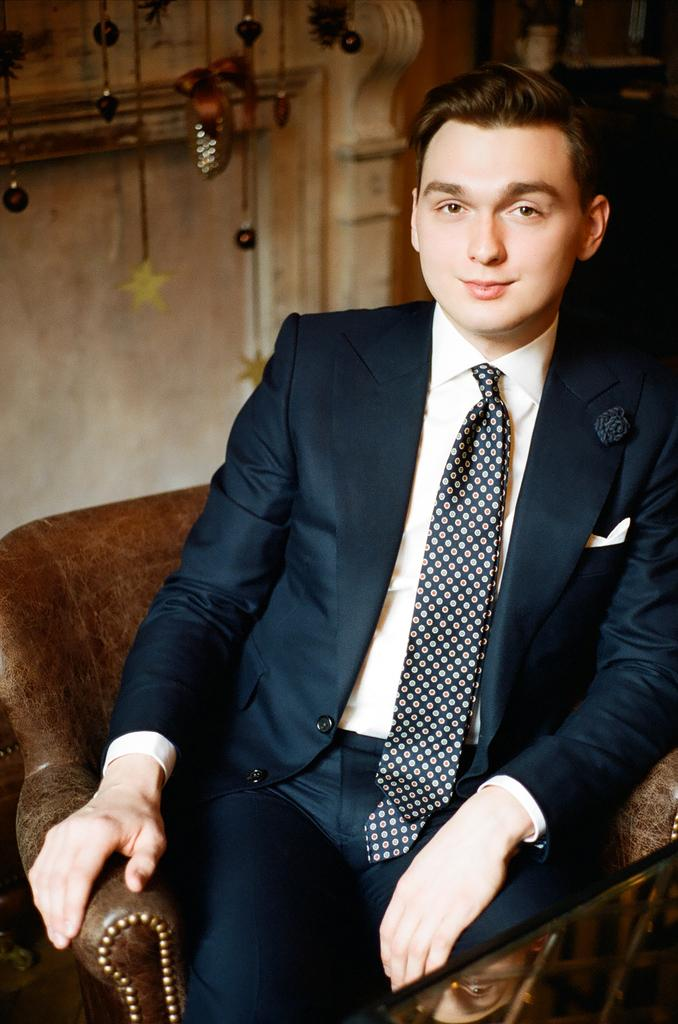Who is present in the image? There is a man in the image. What is the man doing in the image? The man is sitting on a sofa chair. What is in front of the man? There is a glass table in front of the man. What can be seen behind the man? There is a wall with a design behind the man. What is hanging on the wall? There are things hanging on the wall. What type of rod is the man using to skate on the polish in the image? There is no rod, skate, or polish present in the image. 